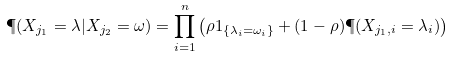<formula> <loc_0><loc_0><loc_500><loc_500>\P ( X _ { j _ { 1 } } = \lambda | X _ { j _ { 2 } } = \omega ) = \prod _ { i = 1 } ^ { n } \left ( \rho 1 _ { \{ \lambda _ { i } = \omega _ { i } \} } + ( 1 - \rho ) \P ( X _ { j _ { 1 } , i } = \lambda _ { i } ) \right )</formula> 